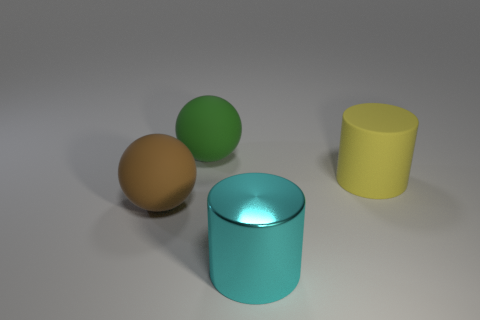Add 4 big rubber balls. How many objects exist? 8 Add 4 balls. How many balls are left? 6 Add 1 large rubber spheres. How many large rubber spheres exist? 3 Subtract 0 gray cubes. How many objects are left? 4 Subtract all small gray metallic cubes. Subtract all balls. How many objects are left? 2 